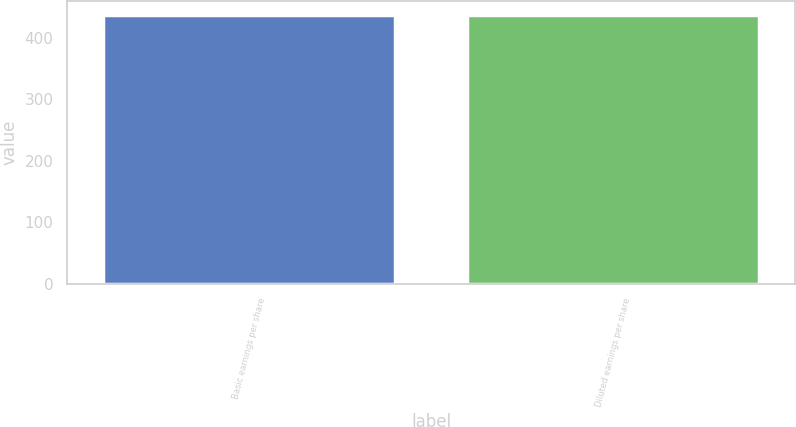Convert chart to OTSL. <chart><loc_0><loc_0><loc_500><loc_500><bar_chart><fcel>Basic earnings per share<fcel>Diluted earnings per share<nl><fcel>437.6<fcel>437.7<nl></chart> 